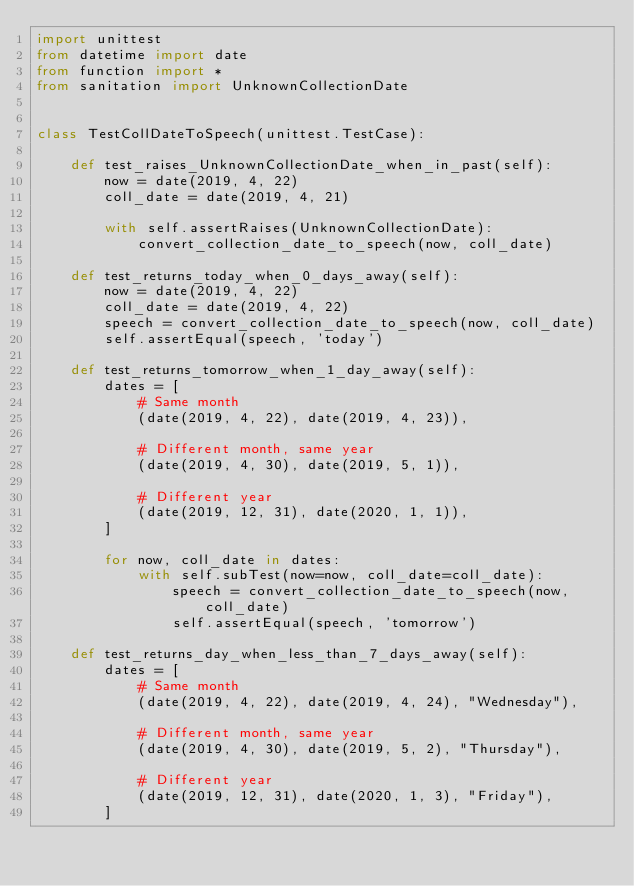<code> <loc_0><loc_0><loc_500><loc_500><_Python_>import unittest
from datetime import date
from function import *
from sanitation import UnknownCollectionDate


class TestCollDateToSpeech(unittest.TestCase):

    def test_raises_UnknownCollectionDate_when_in_past(self):
        now = date(2019, 4, 22)
        coll_date = date(2019, 4, 21)

        with self.assertRaises(UnknownCollectionDate):
            convert_collection_date_to_speech(now, coll_date)

    def test_returns_today_when_0_days_away(self):
        now = date(2019, 4, 22)
        coll_date = date(2019, 4, 22)
        speech = convert_collection_date_to_speech(now, coll_date)
        self.assertEqual(speech, 'today')

    def test_returns_tomorrow_when_1_day_away(self):
        dates = [
            # Same month
            (date(2019, 4, 22), date(2019, 4, 23)),

            # Different month, same year
            (date(2019, 4, 30), date(2019, 5, 1)),

            # Different year
            (date(2019, 12, 31), date(2020, 1, 1)),
        ]

        for now, coll_date in dates:
            with self.subTest(now=now, coll_date=coll_date):
                speech = convert_collection_date_to_speech(now, coll_date)
                self.assertEqual(speech, 'tomorrow')

    def test_returns_day_when_less_than_7_days_away(self):
        dates = [
            # Same month
            (date(2019, 4, 22), date(2019, 4, 24), "Wednesday"),

            # Different month, same year
            (date(2019, 4, 30), date(2019, 5, 2), "Thursday"),

            # Different year
            (date(2019, 12, 31), date(2020, 1, 3), "Friday"),
        ]
</code> 